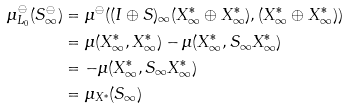<formula> <loc_0><loc_0><loc_500><loc_500>\mu _ { L _ { 0 } } ^ { \ominus } ( S _ { \infty } ^ { \ominus } ) & = \mu ^ { \ominus } ( ( I \oplus S ) _ { \infty } ( X _ { \infty } ^ { \ast } \oplus X _ { \infty } ^ { \ast } ) , ( X _ { \infty } ^ { \ast } \oplus X _ { \infty } ^ { \ast } ) ) \\ & = \mu ( X _ { \infty } ^ { \ast } , X _ { \infty } ^ { \ast } ) - \mu ( X _ { \infty } ^ { \ast } , S _ { \infty } X _ { \infty } ^ { \ast } ) \\ & = - \mu ( X _ { \infty } ^ { \ast } , S _ { \infty } X _ { \infty } ^ { \ast } ) \\ & = \mu _ { X ^ { \ast } } ( S _ { \infty } )</formula> 